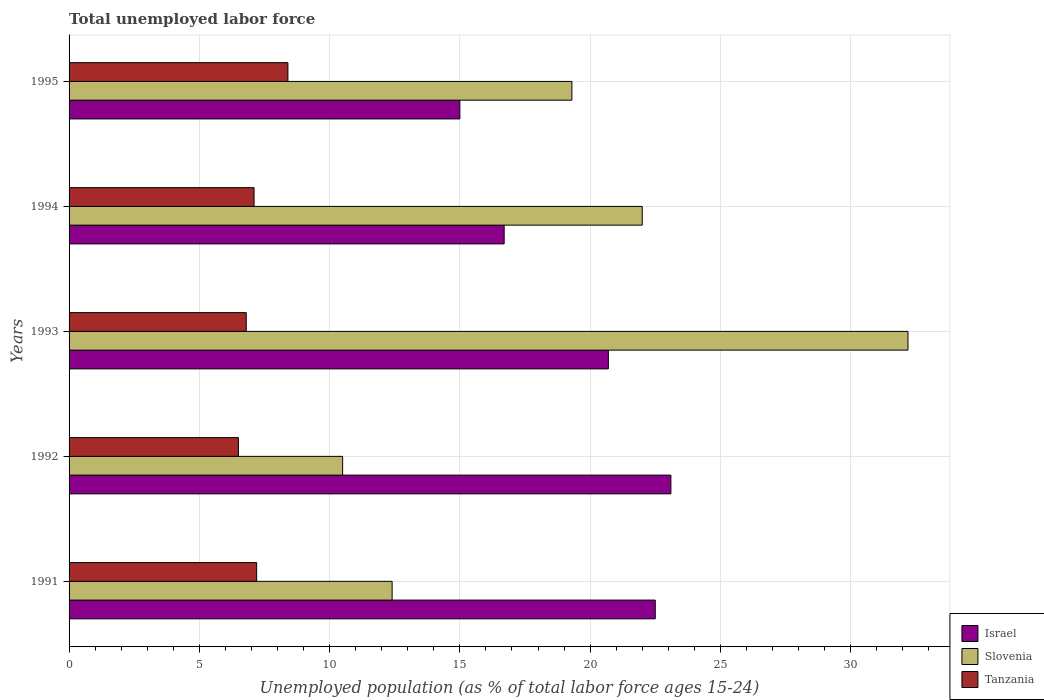How many different coloured bars are there?
Provide a succinct answer. 3. Are the number of bars per tick equal to the number of legend labels?
Keep it short and to the point. Yes. How many bars are there on the 5th tick from the bottom?
Ensure brevity in your answer.  3. What is the label of the 5th group of bars from the top?
Offer a terse response. 1991. In how many cases, is the number of bars for a given year not equal to the number of legend labels?
Offer a terse response. 0. Across all years, what is the maximum percentage of unemployed population in in Israel?
Make the answer very short. 23.1. What is the total percentage of unemployed population in in Slovenia in the graph?
Offer a terse response. 96.4. What is the difference between the percentage of unemployed population in in Slovenia in 1991 and that in 1993?
Offer a terse response. -19.8. What is the difference between the percentage of unemployed population in in Israel in 1992 and the percentage of unemployed population in in Slovenia in 1995?
Keep it short and to the point. 3.8. What is the average percentage of unemployed population in in Tanzania per year?
Make the answer very short. 7.2. In how many years, is the percentage of unemployed population in in Slovenia greater than 25 %?
Your answer should be very brief. 1. What is the ratio of the percentage of unemployed population in in Tanzania in 1991 to that in 1994?
Your answer should be very brief. 1.01. Is the difference between the percentage of unemployed population in in Tanzania in 1992 and 1995 greater than the difference between the percentage of unemployed population in in Slovenia in 1992 and 1995?
Your response must be concise. Yes. What is the difference between the highest and the second highest percentage of unemployed population in in Israel?
Provide a short and direct response. 0.6. What is the difference between the highest and the lowest percentage of unemployed population in in Israel?
Offer a very short reply. 8.1. Is the sum of the percentage of unemployed population in in Slovenia in 1992 and 1993 greater than the maximum percentage of unemployed population in in Tanzania across all years?
Your response must be concise. Yes. How many bars are there?
Provide a short and direct response. 15. How many years are there in the graph?
Provide a short and direct response. 5. What is the difference between two consecutive major ticks on the X-axis?
Your response must be concise. 5. Does the graph contain any zero values?
Make the answer very short. No. How many legend labels are there?
Offer a terse response. 3. How are the legend labels stacked?
Ensure brevity in your answer.  Vertical. What is the title of the graph?
Give a very brief answer. Total unemployed labor force. Does "Sri Lanka" appear as one of the legend labels in the graph?
Give a very brief answer. No. What is the label or title of the X-axis?
Ensure brevity in your answer.  Unemployed population (as % of total labor force ages 15-24). What is the label or title of the Y-axis?
Your answer should be compact. Years. What is the Unemployed population (as % of total labor force ages 15-24) of Israel in 1991?
Offer a terse response. 22.5. What is the Unemployed population (as % of total labor force ages 15-24) in Slovenia in 1991?
Offer a very short reply. 12.4. What is the Unemployed population (as % of total labor force ages 15-24) in Tanzania in 1991?
Your response must be concise. 7.2. What is the Unemployed population (as % of total labor force ages 15-24) of Israel in 1992?
Make the answer very short. 23.1. What is the Unemployed population (as % of total labor force ages 15-24) of Israel in 1993?
Offer a very short reply. 20.7. What is the Unemployed population (as % of total labor force ages 15-24) in Slovenia in 1993?
Offer a terse response. 32.2. What is the Unemployed population (as % of total labor force ages 15-24) in Tanzania in 1993?
Give a very brief answer. 6.8. What is the Unemployed population (as % of total labor force ages 15-24) of Israel in 1994?
Make the answer very short. 16.7. What is the Unemployed population (as % of total labor force ages 15-24) of Slovenia in 1994?
Make the answer very short. 22. What is the Unemployed population (as % of total labor force ages 15-24) in Tanzania in 1994?
Keep it short and to the point. 7.1. What is the Unemployed population (as % of total labor force ages 15-24) in Israel in 1995?
Offer a terse response. 15. What is the Unemployed population (as % of total labor force ages 15-24) in Slovenia in 1995?
Offer a terse response. 19.3. What is the Unemployed population (as % of total labor force ages 15-24) of Tanzania in 1995?
Ensure brevity in your answer.  8.4. Across all years, what is the maximum Unemployed population (as % of total labor force ages 15-24) in Israel?
Offer a very short reply. 23.1. Across all years, what is the maximum Unemployed population (as % of total labor force ages 15-24) in Slovenia?
Offer a terse response. 32.2. Across all years, what is the maximum Unemployed population (as % of total labor force ages 15-24) in Tanzania?
Your answer should be very brief. 8.4. Across all years, what is the minimum Unemployed population (as % of total labor force ages 15-24) of Tanzania?
Ensure brevity in your answer.  6.5. What is the total Unemployed population (as % of total labor force ages 15-24) of Slovenia in the graph?
Provide a succinct answer. 96.4. What is the total Unemployed population (as % of total labor force ages 15-24) in Tanzania in the graph?
Make the answer very short. 36. What is the difference between the Unemployed population (as % of total labor force ages 15-24) of Israel in 1991 and that in 1992?
Ensure brevity in your answer.  -0.6. What is the difference between the Unemployed population (as % of total labor force ages 15-24) in Tanzania in 1991 and that in 1992?
Provide a short and direct response. 0.7. What is the difference between the Unemployed population (as % of total labor force ages 15-24) of Slovenia in 1991 and that in 1993?
Your answer should be compact. -19.8. What is the difference between the Unemployed population (as % of total labor force ages 15-24) in Tanzania in 1991 and that in 1993?
Make the answer very short. 0.4. What is the difference between the Unemployed population (as % of total labor force ages 15-24) in Israel in 1991 and that in 1994?
Provide a short and direct response. 5.8. What is the difference between the Unemployed population (as % of total labor force ages 15-24) in Slovenia in 1991 and that in 1995?
Provide a succinct answer. -6.9. What is the difference between the Unemployed population (as % of total labor force ages 15-24) of Tanzania in 1991 and that in 1995?
Give a very brief answer. -1.2. What is the difference between the Unemployed population (as % of total labor force ages 15-24) in Slovenia in 1992 and that in 1993?
Provide a short and direct response. -21.7. What is the difference between the Unemployed population (as % of total labor force ages 15-24) of Israel in 1992 and that in 1994?
Make the answer very short. 6.4. What is the difference between the Unemployed population (as % of total labor force ages 15-24) of Slovenia in 1992 and that in 1994?
Offer a terse response. -11.5. What is the difference between the Unemployed population (as % of total labor force ages 15-24) in Tanzania in 1992 and that in 1994?
Your answer should be compact. -0.6. What is the difference between the Unemployed population (as % of total labor force ages 15-24) of Slovenia in 1992 and that in 1995?
Ensure brevity in your answer.  -8.8. What is the difference between the Unemployed population (as % of total labor force ages 15-24) in Tanzania in 1992 and that in 1995?
Offer a terse response. -1.9. What is the difference between the Unemployed population (as % of total labor force ages 15-24) of Israel in 1993 and that in 1994?
Your answer should be very brief. 4. What is the difference between the Unemployed population (as % of total labor force ages 15-24) of Slovenia in 1993 and that in 1994?
Keep it short and to the point. 10.2. What is the difference between the Unemployed population (as % of total labor force ages 15-24) of Tanzania in 1993 and that in 1994?
Offer a terse response. -0.3. What is the difference between the Unemployed population (as % of total labor force ages 15-24) in Israel in 1993 and that in 1995?
Your answer should be very brief. 5.7. What is the difference between the Unemployed population (as % of total labor force ages 15-24) of Slovenia in 1993 and that in 1995?
Give a very brief answer. 12.9. What is the difference between the Unemployed population (as % of total labor force ages 15-24) of Israel in 1991 and the Unemployed population (as % of total labor force ages 15-24) of Slovenia in 1992?
Ensure brevity in your answer.  12. What is the difference between the Unemployed population (as % of total labor force ages 15-24) of Israel in 1991 and the Unemployed population (as % of total labor force ages 15-24) of Tanzania in 1993?
Your answer should be compact. 15.7. What is the difference between the Unemployed population (as % of total labor force ages 15-24) of Israel in 1991 and the Unemployed population (as % of total labor force ages 15-24) of Slovenia in 1995?
Your response must be concise. 3.2. What is the difference between the Unemployed population (as % of total labor force ages 15-24) in Slovenia in 1991 and the Unemployed population (as % of total labor force ages 15-24) in Tanzania in 1995?
Offer a terse response. 4. What is the difference between the Unemployed population (as % of total labor force ages 15-24) in Israel in 1992 and the Unemployed population (as % of total labor force ages 15-24) in Tanzania in 1993?
Offer a very short reply. 16.3. What is the difference between the Unemployed population (as % of total labor force ages 15-24) of Slovenia in 1992 and the Unemployed population (as % of total labor force ages 15-24) of Tanzania in 1994?
Your answer should be very brief. 3.4. What is the difference between the Unemployed population (as % of total labor force ages 15-24) in Israel in 1992 and the Unemployed population (as % of total labor force ages 15-24) in Tanzania in 1995?
Provide a short and direct response. 14.7. What is the difference between the Unemployed population (as % of total labor force ages 15-24) of Slovenia in 1993 and the Unemployed population (as % of total labor force ages 15-24) of Tanzania in 1994?
Provide a succinct answer. 25.1. What is the difference between the Unemployed population (as % of total labor force ages 15-24) of Israel in 1993 and the Unemployed population (as % of total labor force ages 15-24) of Slovenia in 1995?
Ensure brevity in your answer.  1.4. What is the difference between the Unemployed population (as % of total labor force ages 15-24) of Israel in 1993 and the Unemployed population (as % of total labor force ages 15-24) of Tanzania in 1995?
Make the answer very short. 12.3. What is the difference between the Unemployed population (as % of total labor force ages 15-24) in Slovenia in 1993 and the Unemployed population (as % of total labor force ages 15-24) in Tanzania in 1995?
Your response must be concise. 23.8. What is the difference between the Unemployed population (as % of total labor force ages 15-24) in Israel in 1994 and the Unemployed population (as % of total labor force ages 15-24) in Slovenia in 1995?
Your answer should be compact. -2.6. What is the difference between the Unemployed population (as % of total labor force ages 15-24) in Israel in 1994 and the Unemployed population (as % of total labor force ages 15-24) in Tanzania in 1995?
Provide a short and direct response. 8.3. What is the difference between the Unemployed population (as % of total labor force ages 15-24) of Slovenia in 1994 and the Unemployed population (as % of total labor force ages 15-24) of Tanzania in 1995?
Give a very brief answer. 13.6. What is the average Unemployed population (as % of total labor force ages 15-24) of Israel per year?
Give a very brief answer. 19.6. What is the average Unemployed population (as % of total labor force ages 15-24) of Slovenia per year?
Offer a terse response. 19.28. In the year 1991, what is the difference between the Unemployed population (as % of total labor force ages 15-24) of Israel and Unemployed population (as % of total labor force ages 15-24) of Slovenia?
Provide a succinct answer. 10.1. In the year 1991, what is the difference between the Unemployed population (as % of total labor force ages 15-24) in Israel and Unemployed population (as % of total labor force ages 15-24) in Tanzania?
Make the answer very short. 15.3. In the year 1992, what is the difference between the Unemployed population (as % of total labor force ages 15-24) of Israel and Unemployed population (as % of total labor force ages 15-24) of Slovenia?
Offer a very short reply. 12.6. In the year 1992, what is the difference between the Unemployed population (as % of total labor force ages 15-24) of Israel and Unemployed population (as % of total labor force ages 15-24) of Tanzania?
Your answer should be compact. 16.6. In the year 1993, what is the difference between the Unemployed population (as % of total labor force ages 15-24) in Slovenia and Unemployed population (as % of total labor force ages 15-24) in Tanzania?
Make the answer very short. 25.4. In the year 1994, what is the difference between the Unemployed population (as % of total labor force ages 15-24) in Israel and Unemployed population (as % of total labor force ages 15-24) in Tanzania?
Your response must be concise. 9.6. In the year 1995, what is the difference between the Unemployed population (as % of total labor force ages 15-24) of Israel and Unemployed population (as % of total labor force ages 15-24) of Tanzania?
Your answer should be compact. 6.6. In the year 1995, what is the difference between the Unemployed population (as % of total labor force ages 15-24) in Slovenia and Unemployed population (as % of total labor force ages 15-24) in Tanzania?
Offer a terse response. 10.9. What is the ratio of the Unemployed population (as % of total labor force ages 15-24) in Slovenia in 1991 to that in 1992?
Offer a terse response. 1.18. What is the ratio of the Unemployed population (as % of total labor force ages 15-24) of Tanzania in 1991 to that in 1992?
Offer a terse response. 1.11. What is the ratio of the Unemployed population (as % of total labor force ages 15-24) of Israel in 1991 to that in 1993?
Provide a succinct answer. 1.09. What is the ratio of the Unemployed population (as % of total labor force ages 15-24) in Slovenia in 1991 to that in 1993?
Your answer should be very brief. 0.39. What is the ratio of the Unemployed population (as % of total labor force ages 15-24) of Tanzania in 1991 to that in 1993?
Ensure brevity in your answer.  1.06. What is the ratio of the Unemployed population (as % of total labor force ages 15-24) in Israel in 1991 to that in 1994?
Give a very brief answer. 1.35. What is the ratio of the Unemployed population (as % of total labor force ages 15-24) in Slovenia in 1991 to that in 1994?
Offer a terse response. 0.56. What is the ratio of the Unemployed population (as % of total labor force ages 15-24) of Tanzania in 1991 to that in 1994?
Provide a short and direct response. 1.01. What is the ratio of the Unemployed population (as % of total labor force ages 15-24) in Israel in 1991 to that in 1995?
Offer a terse response. 1.5. What is the ratio of the Unemployed population (as % of total labor force ages 15-24) in Slovenia in 1991 to that in 1995?
Provide a succinct answer. 0.64. What is the ratio of the Unemployed population (as % of total labor force ages 15-24) in Israel in 1992 to that in 1993?
Offer a very short reply. 1.12. What is the ratio of the Unemployed population (as % of total labor force ages 15-24) in Slovenia in 1992 to that in 1993?
Your response must be concise. 0.33. What is the ratio of the Unemployed population (as % of total labor force ages 15-24) of Tanzania in 1992 to that in 1993?
Offer a very short reply. 0.96. What is the ratio of the Unemployed population (as % of total labor force ages 15-24) in Israel in 1992 to that in 1994?
Give a very brief answer. 1.38. What is the ratio of the Unemployed population (as % of total labor force ages 15-24) in Slovenia in 1992 to that in 1994?
Your answer should be compact. 0.48. What is the ratio of the Unemployed population (as % of total labor force ages 15-24) of Tanzania in 1992 to that in 1994?
Make the answer very short. 0.92. What is the ratio of the Unemployed population (as % of total labor force ages 15-24) in Israel in 1992 to that in 1995?
Provide a succinct answer. 1.54. What is the ratio of the Unemployed population (as % of total labor force ages 15-24) in Slovenia in 1992 to that in 1995?
Ensure brevity in your answer.  0.54. What is the ratio of the Unemployed population (as % of total labor force ages 15-24) of Tanzania in 1992 to that in 1995?
Offer a very short reply. 0.77. What is the ratio of the Unemployed population (as % of total labor force ages 15-24) in Israel in 1993 to that in 1994?
Keep it short and to the point. 1.24. What is the ratio of the Unemployed population (as % of total labor force ages 15-24) in Slovenia in 1993 to that in 1994?
Keep it short and to the point. 1.46. What is the ratio of the Unemployed population (as % of total labor force ages 15-24) of Tanzania in 1993 to that in 1994?
Make the answer very short. 0.96. What is the ratio of the Unemployed population (as % of total labor force ages 15-24) in Israel in 1993 to that in 1995?
Provide a succinct answer. 1.38. What is the ratio of the Unemployed population (as % of total labor force ages 15-24) of Slovenia in 1993 to that in 1995?
Your answer should be compact. 1.67. What is the ratio of the Unemployed population (as % of total labor force ages 15-24) in Tanzania in 1993 to that in 1995?
Ensure brevity in your answer.  0.81. What is the ratio of the Unemployed population (as % of total labor force ages 15-24) of Israel in 1994 to that in 1995?
Give a very brief answer. 1.11. What is the ratio of the Unemployed population (as % of total labor force ages 15-24) in Slovenia in 1994 to that in 1995?
Keep it short and to the point. 1.14. What is the ratio of the Unemployed population (as % of total labor force ages 15-24) in Tanzania in 1994 to that in 1995?
Keep it short and to the point. 0.85. What is the difference between the highest and the second highest Unemployed population (as % of total labor force ages 15-24) of Israel?
Your response must be concise. 0.6. What is the difference between the highest and the lowest Unemployed population (as % of total labor force ages 15-24) in Slovenia?
Keep it short and to the point. 21.7. What is the difference between the highest and the lowest Unemployed population (as % of total labor force ages 15-24) in Tanzania?
Your response must be concise. 1.9. 